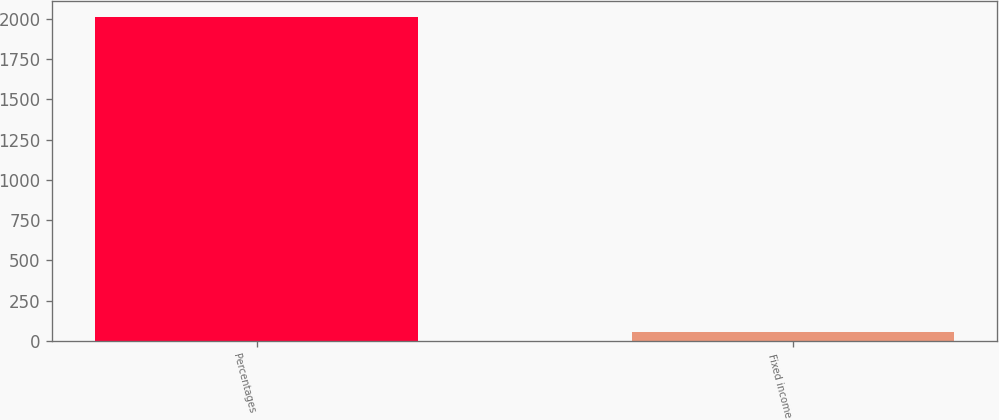Convert chart to OTSL. <chart><loc_0><loc_0><loc_500><loc_500><bar_chart><fcel>Percentages<fcel>Fixed income<nl><fcel>2012<fcel>56<nl></chart> 